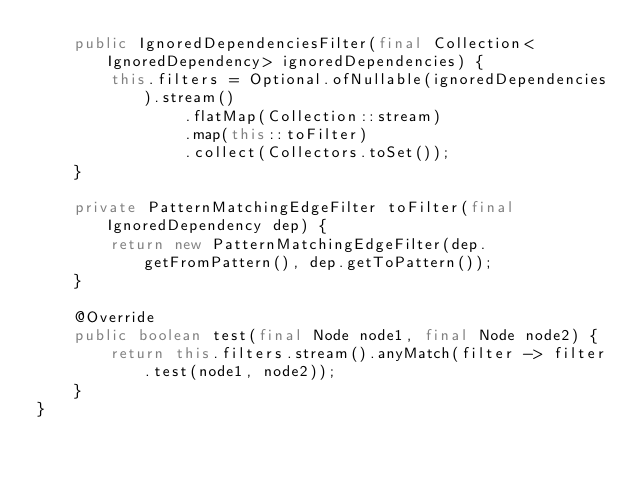Convert code to text. <code><loc_0><loc_0><loc_500><loc_500><_Java_>    public IgnoredDependenciesFilter(final Collection<IgnoredDependency> ignoredDependencies) {
        this.filters = Optional.ofNullable(ignoredDependencies).stream()
                .flatMap(Collection::stream)
                .map(this::toFilter)
                .collect(Collectors.toSet());
    }

    private PatternMatchingEdgeFilter toFilter(final IgnoredDependency dep) {
        return new PatternMatchingEdgeFilter(dep.getFromPattern(), dep.getToPattern());
    }

    @Override
    public boolean test(final Node node1, final Node node2) {
        return this.filters.stream().anyMatch(filter -> filter.test(node1, node2));
    }
}
</code> 